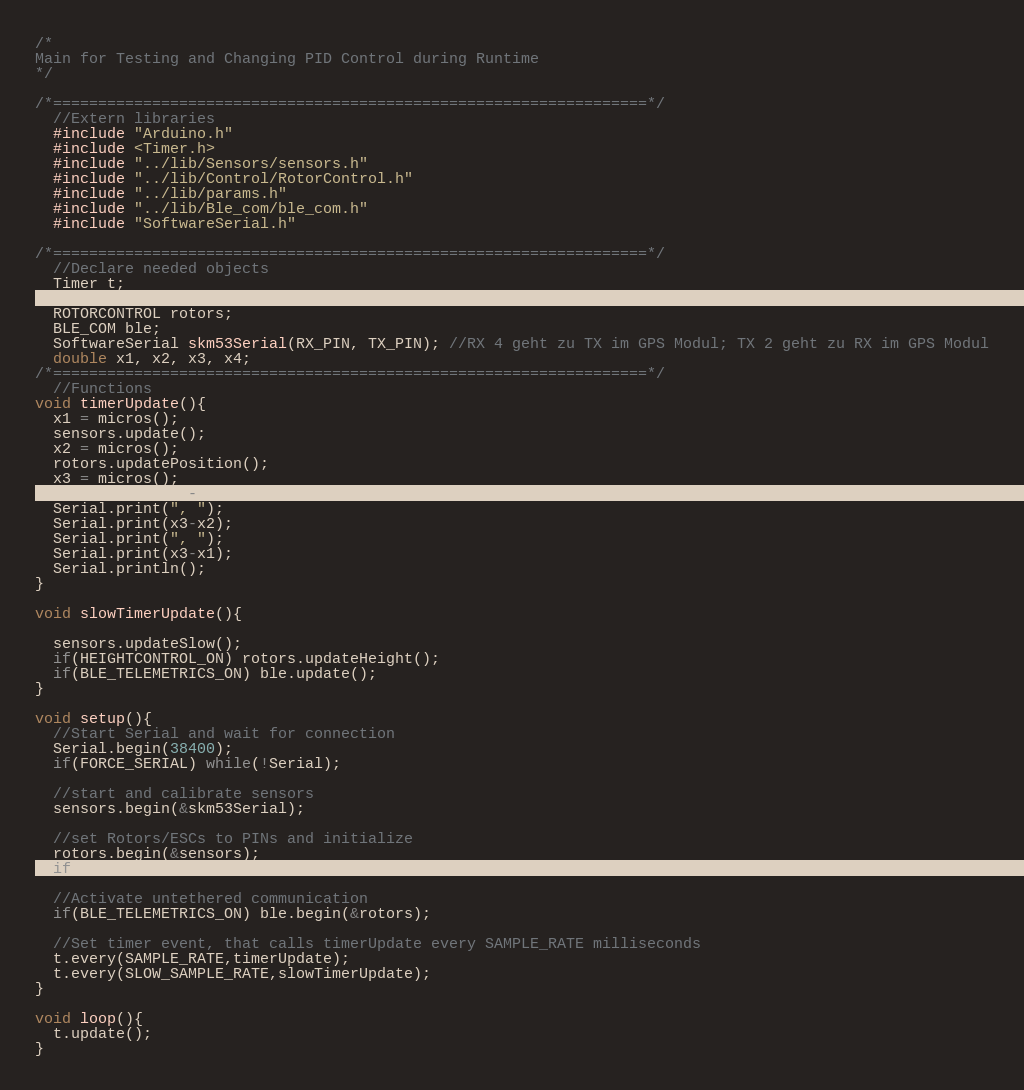<code> <loc_0><loc_0><loc_500><loc_500><_C++_>/*
Main for Testing and Changing PID Control during Runtime
*/

/*==================================================================*/
  //Extern libraries
  #include "Arduino.h"
  #include <Timer.h>
  #include "../lib/Sensors/sensors.h"
  #include "../lib/Control/RotorControl.h"
  #include "../lib/params.h"
  #include "../lib/Ble_com/ble_com.h"
  #include "SoftwareSerial.h"

/*==================================================================*/
  //Declare needed objects
  Timer t;
  SENSORS sensors;
  ROTORCONTROL rotors;
  BLE_COM ble;
  SoftwareSerial skm53Serial(RX_PIN, TX_PIN); //RX 4 geht zu TX im GPS Modul; TX 2 geht zu RX im GPS Modul
  double x1, x2, x3, x4;
/*==================================================================*/
  //Functions
void timerUpdate(){
  x1 = micros();
  sensors.update();
  x2 = micros();
  rotors.updatePosition();
  x3 = micros();
  Serial.print(x2-x1);
  Serial.print(", ");
  Serial.print(x3-x2);
  Serial.print(", ");
  Serial.print(x3-x1);
  Serial.println();
}

void slowTimerUpdate(){

  sensors.updateSlow();
  if(HEIGHTCONTROL_ON) rotors.updateHeight();
  if(BLE_TELEMETRICS_ON) ble.update();
}

void setup(){
  //Start Serial and wait for connection
  Serial.begin(38400);
  if(FORCE_SERIAL) while(!Serial);

  //start and calibrate sensors
  sensors.begin(&skm53Serial);

  //set Rotors/ESCs to PINs and initialize
  rotors.begin(&sensors);
  if(AUTOSTART) rotors.start(STARTUP_SIGNAL);

  //Activate untethered communication
  if(BLE_TELEMETRICS_ON) ble.begin(&rotors);

  //Set timer event, that calls timerUpdate every SAMPLE_RATE milliseconds
  t.every(SAMPLE_RATE,timerUpdate);
  t.every(SLOW_SAMPLE_RATE,slowTimerUpdate);
}

void loop(){
  t.update();
}
</code> 